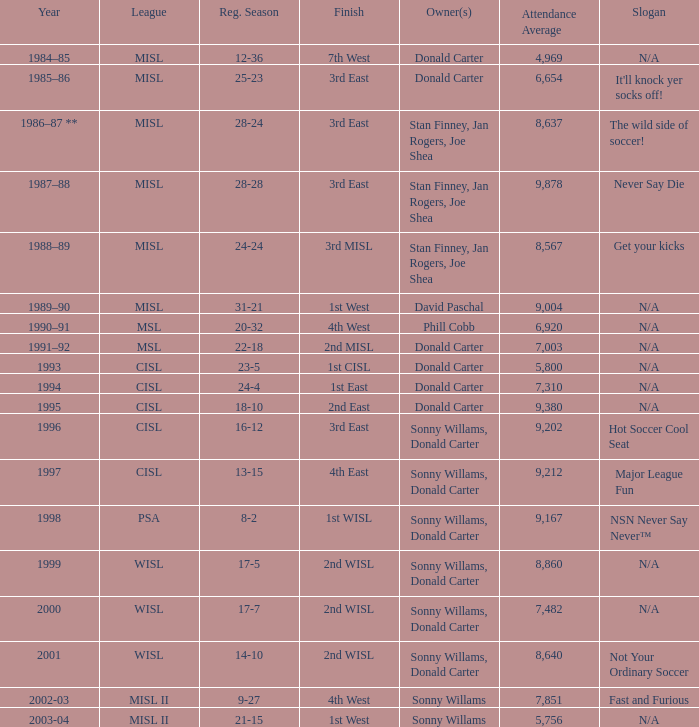What year has the wild side of soccer! as the slogan? 1986–87 **. 